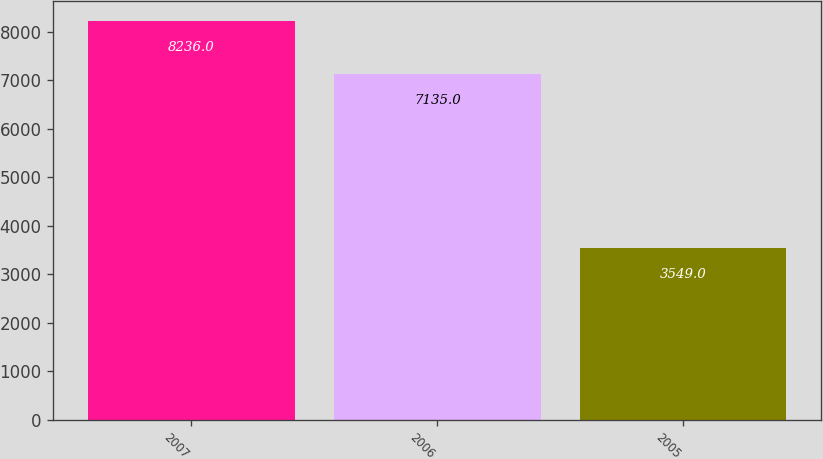<chart> <loc_0><loc_0><loc_500><loc_500><bar_chart><fcel>2007<fcel>2006<fcel>2005<nl><fcel>8236<fcel>7135<fcel>3549<nl></chart> 